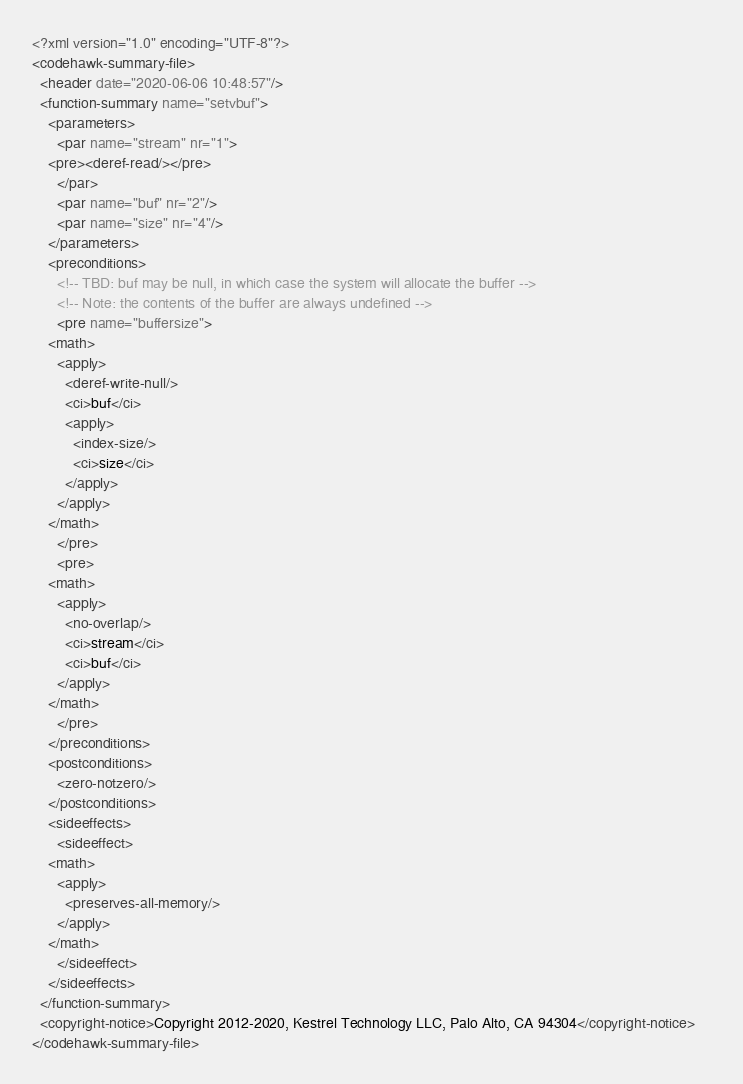Convert code to text. <code><loc_0><loc_0><loc_500><loc_500><_XML_><?xml version="1.0" encoding="UTF-8"?>
<codehawk-summary-file>
  <header date="2020-06-06 10:48:57"/>
  <function-summary name="setvbuf">
    <parameters>
      <par name="stream" nr="1">
	<pre><deref-read/></pre>
      </par>
      <par name="buf" nr="2"/>
      <par name="size" nr="4"/>
    </parameters>
    <preconditions>
      <!-- TBD: buf may be null, in which case the system will allocate the buffer -->
      <!-- Note: the contents of the buffer are always undefined -->
      <pre name="buffersize">
	<math>
	  <apply>
	    <deref-write-null/>
	    <ci>buf</ci>
	    <apply>
	      <index-size/>
	      <ci>size</ci>
	    </apply>
	  </apply>
	</math>
      </pre>
      <pre>
	<math>
	  <apply>
	    <no-overlap/>
	    <ci>stream</ci>
	    <ci>buf</ci>
	  </apply>
	</math>
      </pre>
    </preconditions>
    <postconditions>
      <zero-notzero/>
    </postconditions>
    <sideeffects>
      <sideeffect>
	<math>
	  <apply>
	    <preserves-all-memory/>
	  </apply>
	</math>
      </sideeffect>
    </sideeffects>
  </function-summary>
  <copyright-notice>Copyright 2012-2020, Kestrel Technology LLC, Palo Alto, CA 94304</copyright-notice>    
</codehawk-summary-file>
</code> 